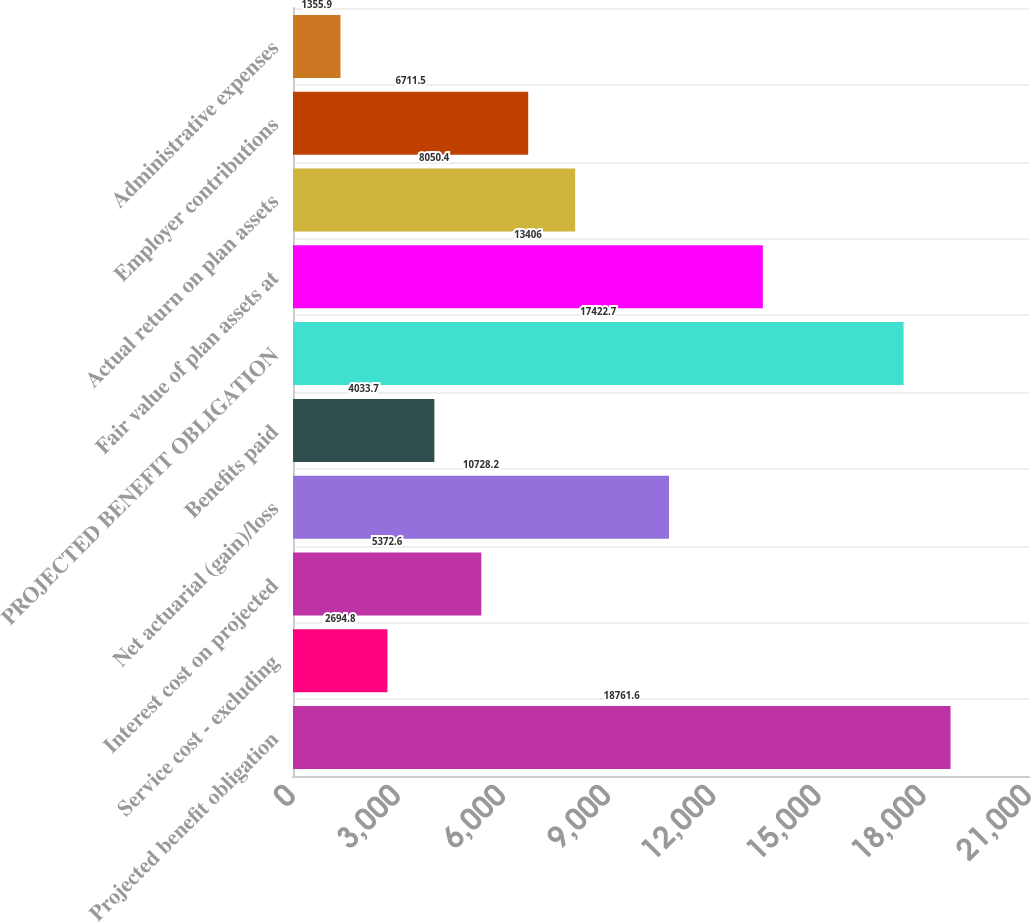Convert chart to OTSL. <chart><loc_0><loc_0><loc_500><loc_500><bar_chart><fcel>Projected benefit obligation<fcel>Service cost - excluding<fcel>Interest cost on projected<fcel>Net actuarial (gain)/loss<fcel>Benefits paid<fcel>PROJECTED BENEFIT OBLIGATION<fcel>Fair value of plan assets at<fcel>Actual return on plan assets<fcel>Employer contributions<fcel>Administrative expenses<nl><fcel>18761.6<fcel>2694.8<fcel>5372.6<fcel>10728.2<fcel>4033.7<fcel>17422.7<fcel>13406<fcel>8050.4<fcel>6711.5<fcel>1355.9<nl></chart> 